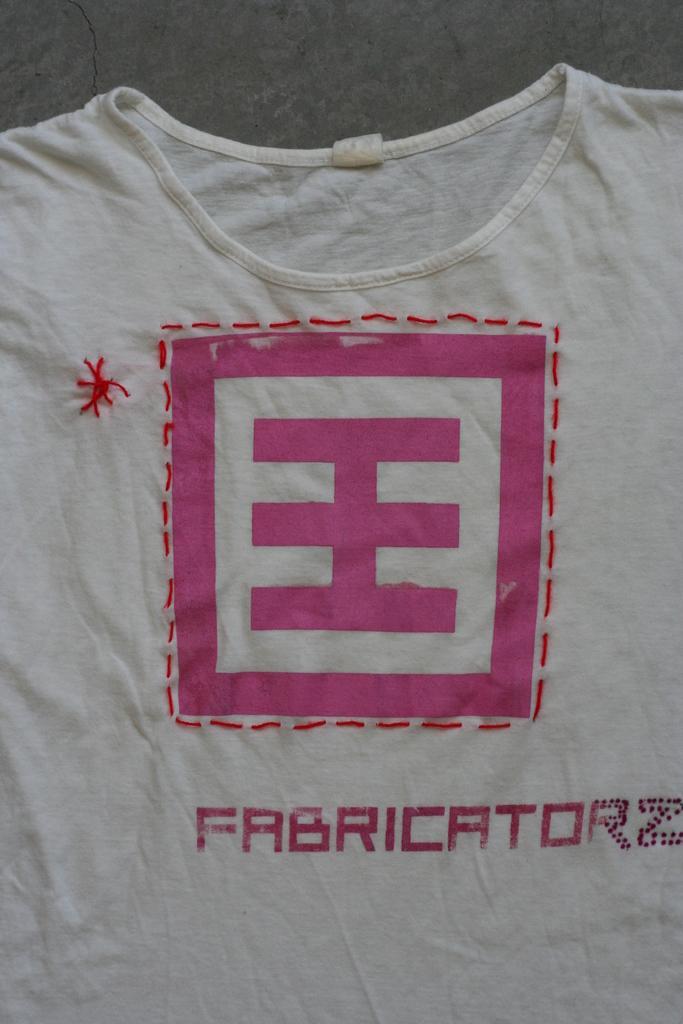Could you give a brief overview of what you see in this image? In this image, we can see a t-shirt which is colored white contains a logo and some text. 